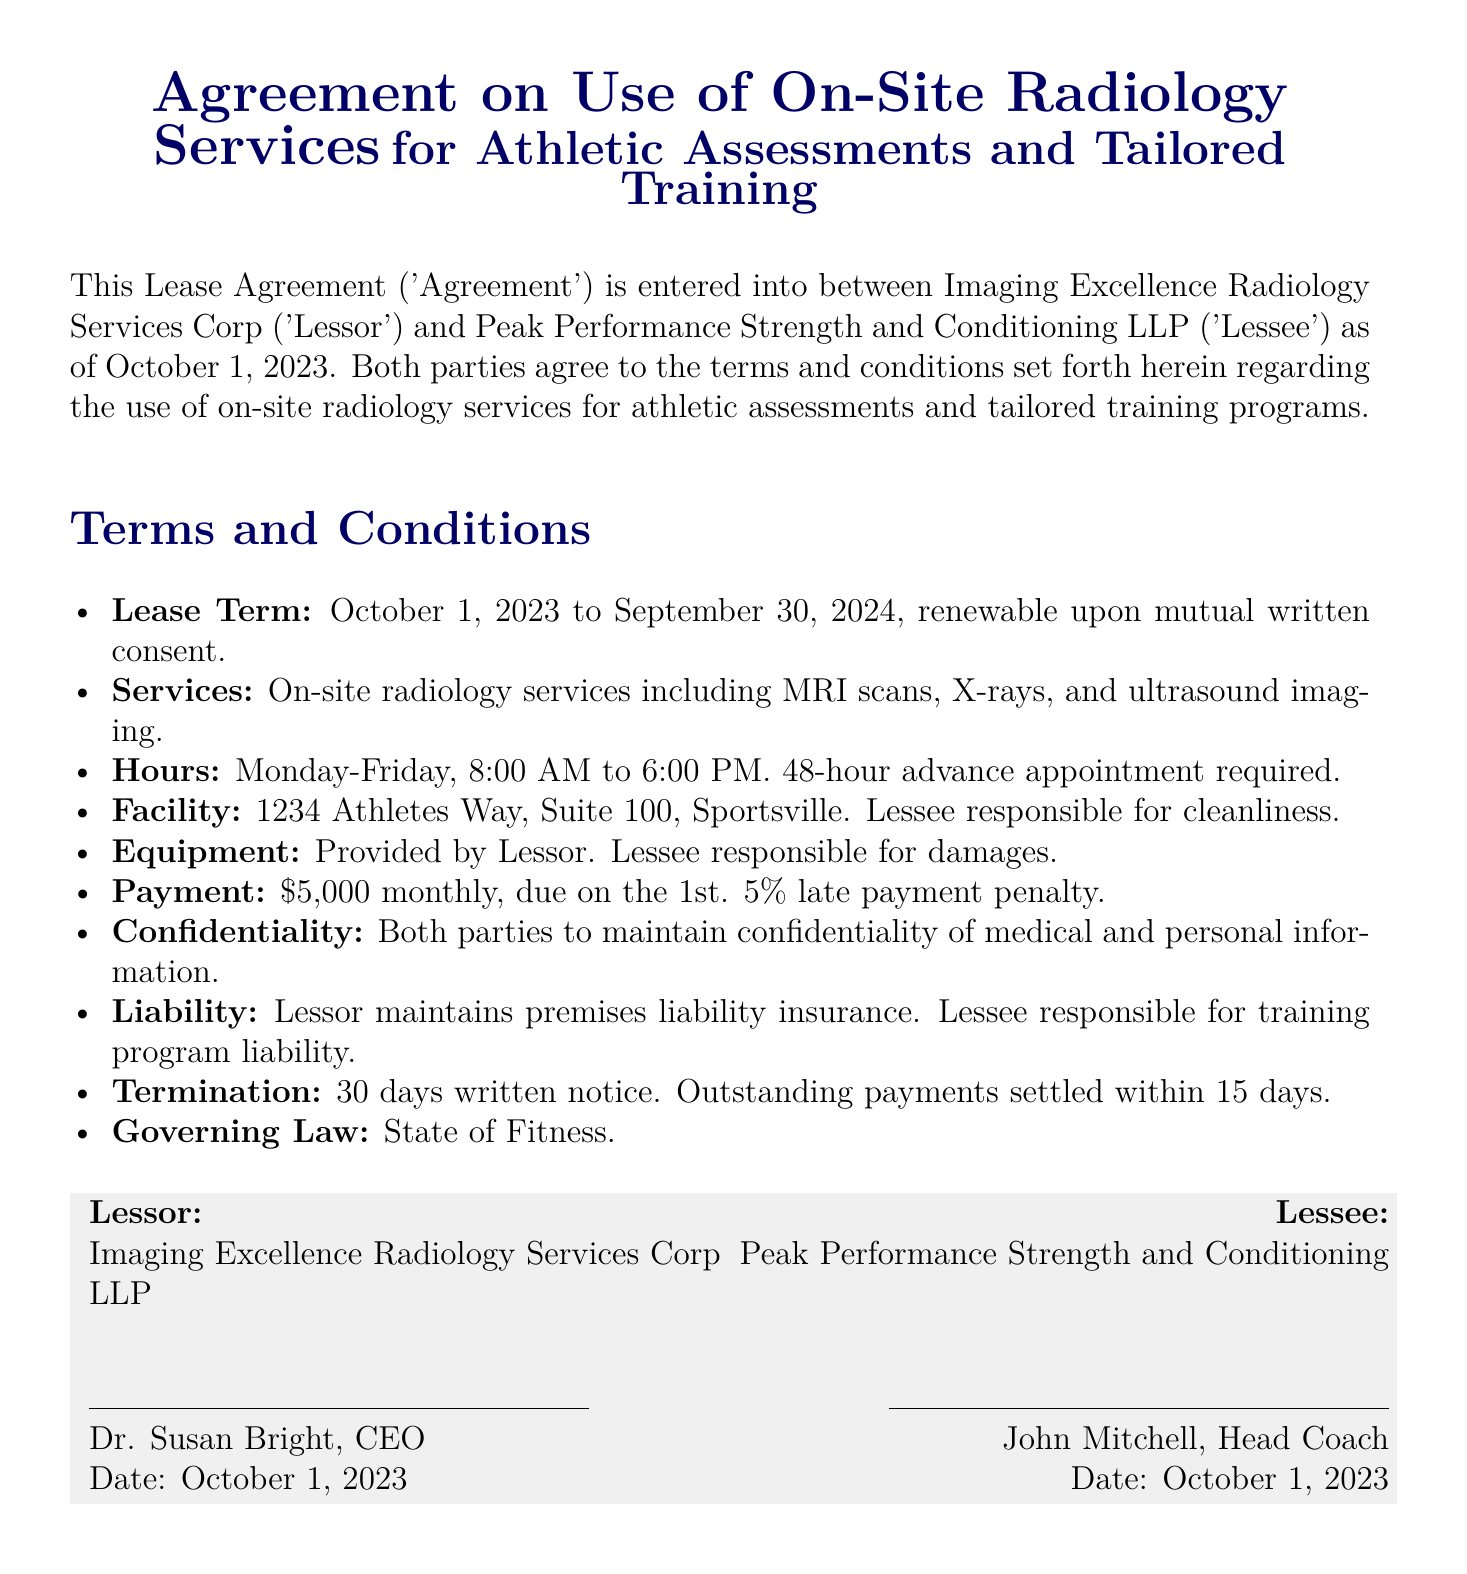What is the Lease Term? The Lease Term is specified in the document as the duration from October 1, 2023, to September 30, 2024.
Answer: October 1, 2023 to September 30, 2024 Who is the Lessor? The document names the party providing the radiology services as Imaging Excellence Radiology Services Corp.
Answer: Imaging Excellence Radiology Services Corp How much is the monthly payment? According to the payment terms laid out in the document, the monthly payment is specified clearly.
Answer: $5,000 What is required for appointment scheduling? The document states that a specific amount of time is necessary prior to appointments, indicating the advance notice required.
Answer: 48-hour advance appointment What is the termination notice period? The document outlines the period required for notifying about termination of the agreement.
Answer: 30 days written notice What liability does the Lessor maintain? In the liability clause, it is specified that Lessor has a certain type of insurance related to their facilities.
Answer: premises liability insurance What are the on-site services provided? The document lists the types of imaging services offered, indicating specific technologies available.
Answer: MRI scans, X-rays, and ultrasound imaging What must Lessee maintain regarding the facility? The document specifies responsibilities that the Lessee has towards the cleanliness of the place used for services.
Answer: cleanliness What is the late payment penalty percentage? The payment terms include a penalty for delayed payments, specified as a percentage in the document.
Answer: 5% 